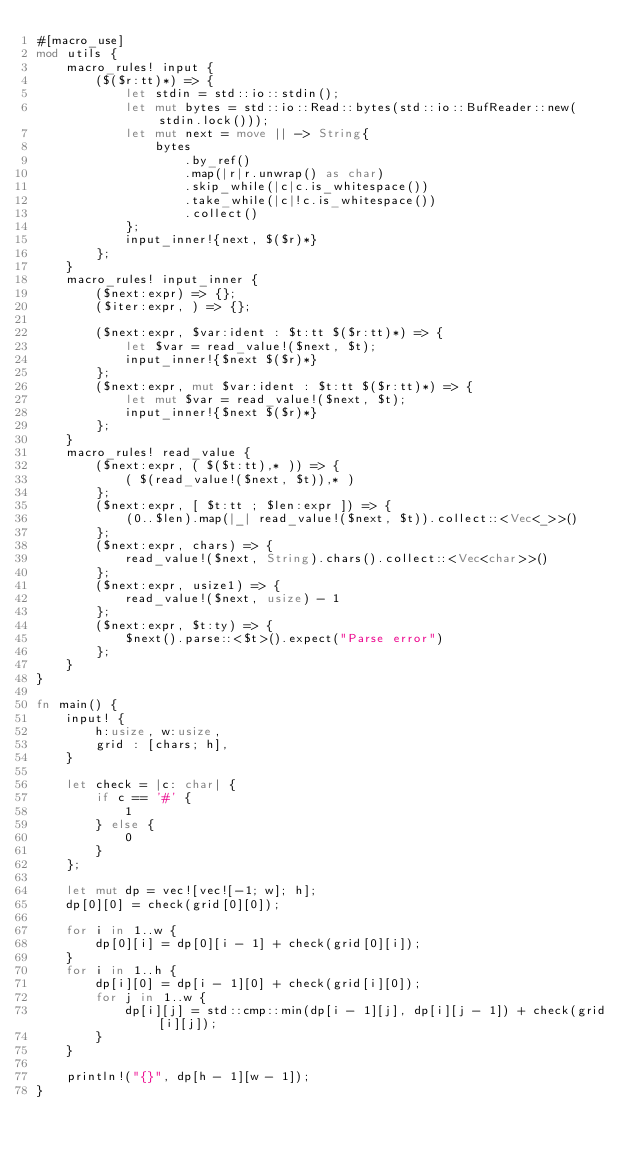<code> <loc_0><loc_0><loc_500><loc_500><_Rust_>#[macro_use]
mod utils {
    macro_rules! input {
        ($($r:tt)*) => {
            let stdin = std::io::stdin();
            let mut bytes = std::io::Read::bytes(std::io::BufReader::new(stdin.lock()));
            let mut next = move || -> String{
                bytes
                    .by_ref()
                    .map(|r|r.unwrap() as char)
                    .skip_while(|c|c.is_whitespace())
                    .take_while(|c|!c.is_whitespace())
                    .collect()
            };
            input_inner!{next, $($r)*}
        };
    }
    macro_rules! input_inner {
        ($next:expr) => {};
        ($iter:expr, ) => {};

        ($next:expr, $var:ident : $t:tt $($r:tt)*) => {
            let $var = read_value!($next, $t);
            input_inner!{$next $($r)*}
        };
        ($next:expr, mut $var:ident : $t:tt $($r:tt)*) => {
            let mut $var = read_value!($next, $t);
            input_inner!{$next $($r)*}
        };
    }
    macro_rules! read_value {
        ($next:expr, ( $($t:tt),* )) => {
            ( $(read_value!($next, $t)),* )
        };
        ($next:expr, [ $t:tt ; $len:expr ]) => {
            (0..$len).map(|_| read_value!($next, $t)).collect::<Vec<_>>()
        };
        ($next:expr, chars) => {
            read_value!($next, String).chars().collect::<Vec<char>>()
        };
        ($next:expr, usize1) => {
            read_value!($next, usize) - 1
        };
        ($next:expr, $t:ty) => {
            $next().parse::<$t>().expect("Parse error")
        };
    }
}

fn main() {
    input! {
        h:usize, w:usize,
        grid : [chars; h],
    }

    let check = |c: char| {
        if c == '#' {
            1
        } else {
            0
        }
    };

    let mut dp = vec![vec![-1; w]; h];
    dp[0][0] = check(grid[0][0]);

    for i in 1..w {
        dp[0][i] = dp[0][i - 1] + check(grid[0][i]);
    }
    for i in 1..h {
        dp[i][0] = dp[i - 1][0] + check(grid[i][0]);
        for j in 1..w {
            dp[i][j] = std::cmp::min(dp[i - 1][j], dp[i][j - 1]) + check(grid[i][j]);
        }
    }

    println!("{}", dp[h - 1][w - 1]);
}
</code> 